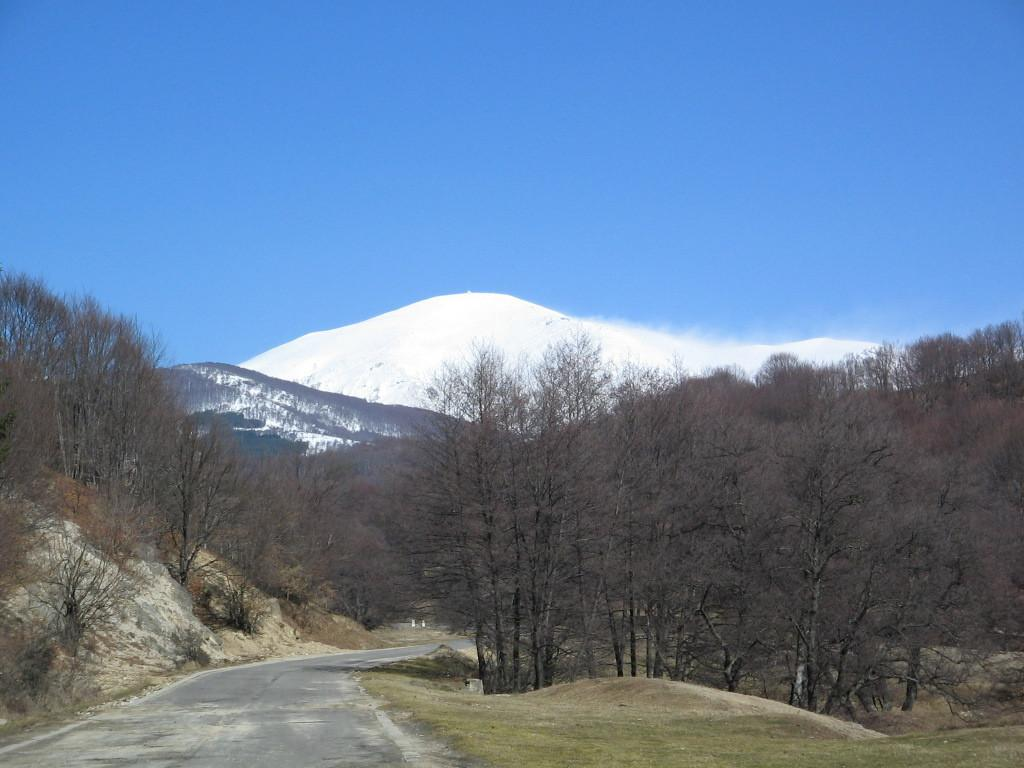What is the main feature of the image? There is a road in the image. What other natural elements can be seen in the image? There are trees in the image. What can be seen in the distance in the image? There are mountains in the background of the image. What is visible in the sky in the image? The sky is visible in the background of the image. What type of treatment is being administered in the room shown in the image? There is no room or treatment present in the image; it features a road, trees, mountains, and the sky. 